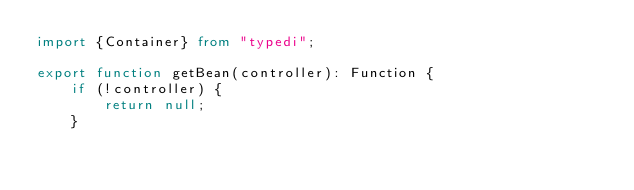Convert code to text. <code><loc_0><loc_0><loc_500><loc_500><_TypeScript_>import {Container} from "typedi";

export function getBean(controller): Function {
    if (!controller) {
        return null;
    }</code> 